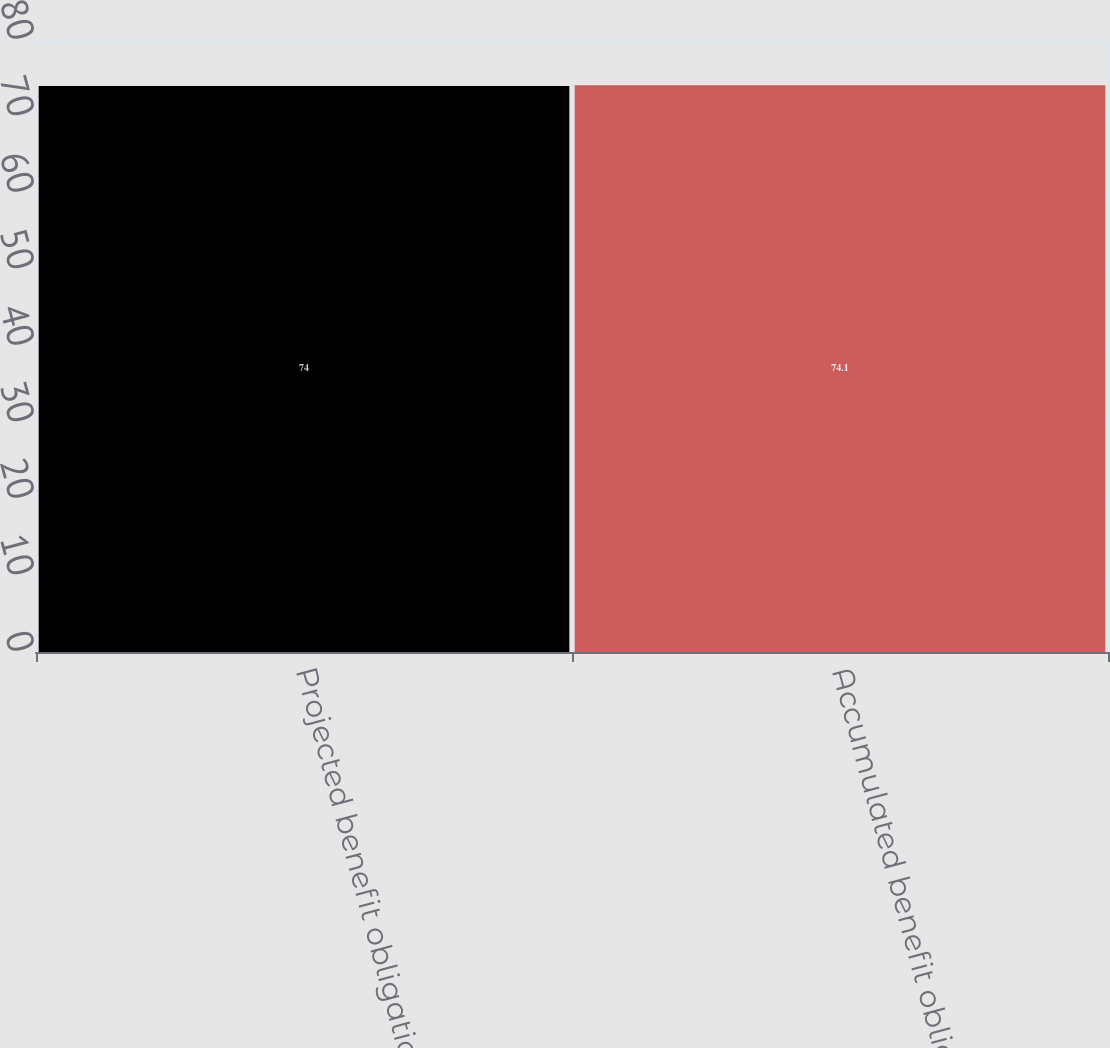<chart> <loc_0><loc_0><loc_500><loc_500><bar_chart><fcel>Projected benefit obligation<fcel>Accumulated benefit obligation<nl><fcel>74<fcel>74.1<nl></chart> 